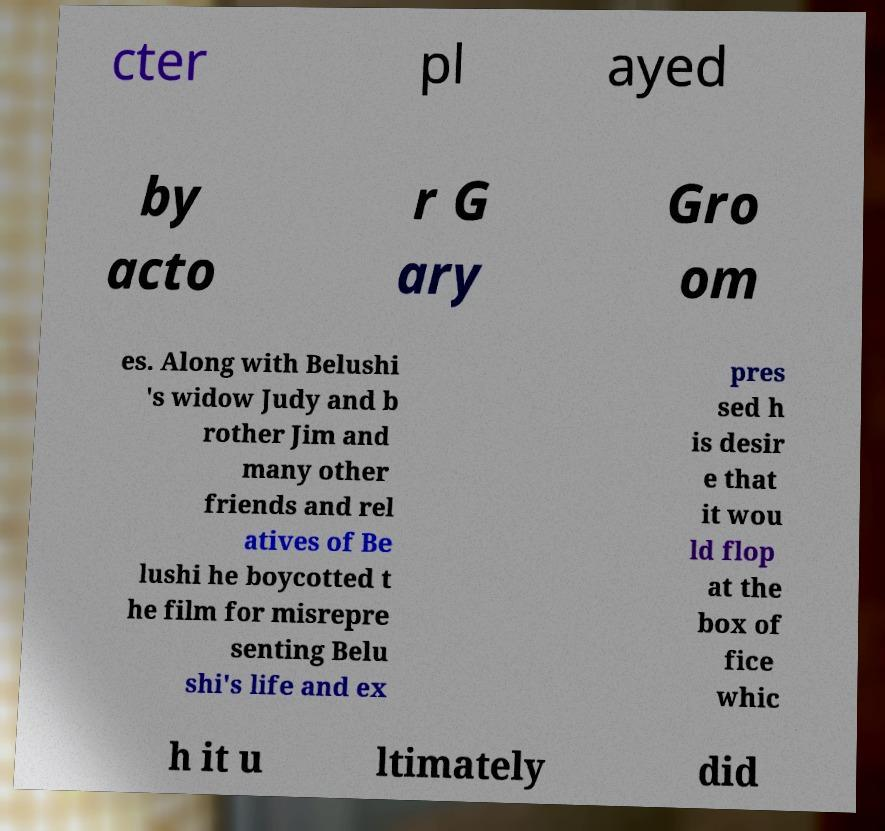Can you accurately transcribe the text from the provided image for me? cter pl ayed by acto r G ary Gro om es. Along with Belushi 's widow Judy and b rother Jim and many other friends and rel atives of Be lushi he boycotted t he film for misrepre senting Belu shi's life and ex pres sed h is desir e that it wou ld flop at the box of fice whic h it u ltimately did 